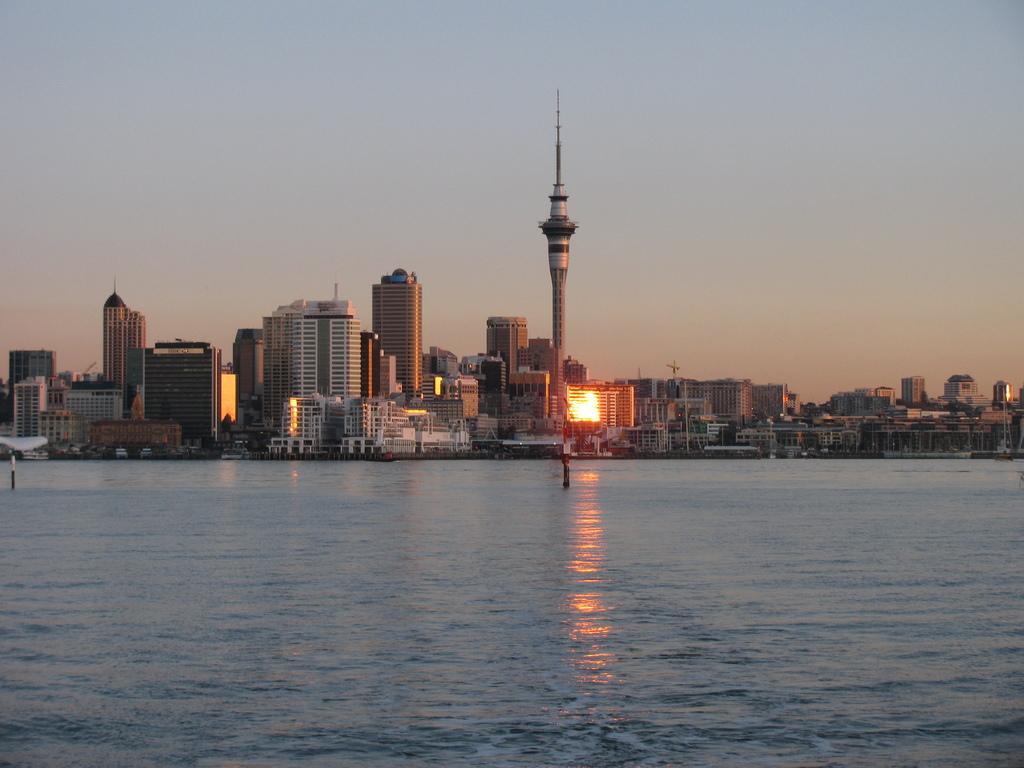Could you give a brief overview of what you see in this image? In this image I can see the water. In the background I can see the light, many buildings and the sky. 